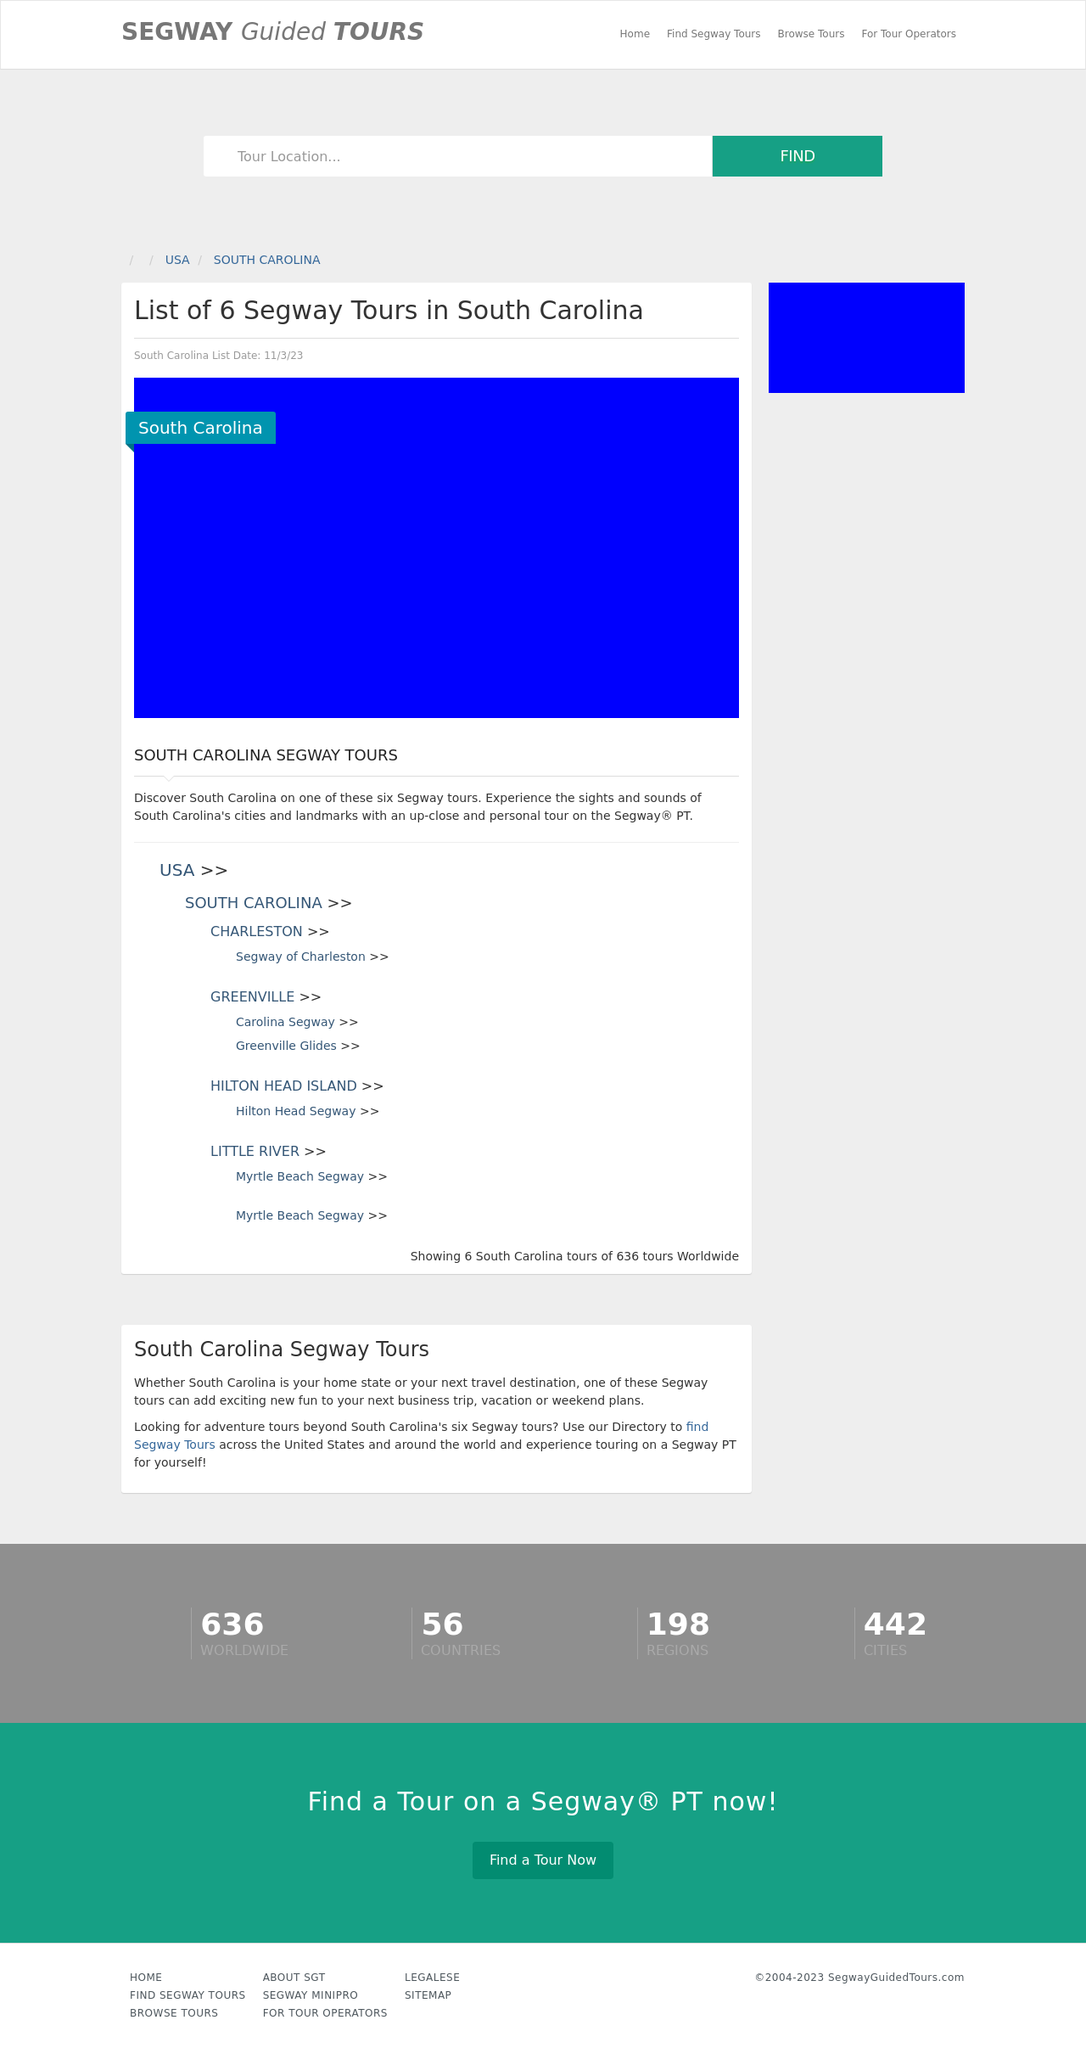Could you detail the process for assembling this website using HTML? To assemble a website using HTML, begin by defining the HTML structure, which involves creating a simple skeleton with elements like <!DOCTYPE html>, <html>, <head>, and <body>. Define sections within <body> using tags like <header>, <nav> for navigation bar, <main> for main content, <footer> for footer, etc. Embed CSS for styling or JavaScript for functionality within the head or link external files. Finally, ensure the HTML is semantic and accessible by using appropriate tags and attributes. The example provided previously appears to be more related to CSS rather than outlining the HTML structural setup needed for a basic web page. 